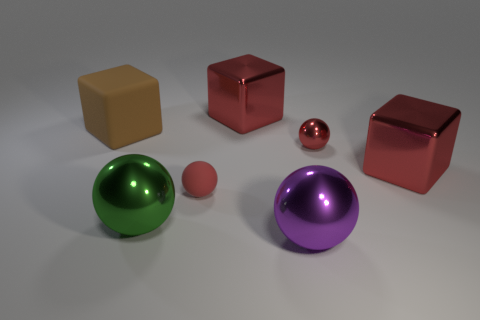Are there any other things that are made of the same material as the large brown cube?
Offer a very short reply. Yes. Is the number of rubber spheres that are behind the large purple shiny sphere the same as the number of blocks to the left of the large rubber thing?
Your response must be concise. No. Are the large brown block and the green thing made of the same material?
Provide a short and direct response. No. How many green objects are balls or small metal spheres?
Your answer should be compact. 1. How many other objects have the same shape as the small metallic thing?
Keep it short and to the point. 3. What is the material of the brown cube?
Your answer should be compact. Rubber. Are there an equal number of large green shiny things that are to the right of the purple metallic object and big brown things?
Keep it short and to the point. No. There is a rubber thing that is the same size as the green ball; what shape is it?
Ensure brevity in your answer.  Cube. There is a matte thing to the right of the green sphere; is there a big thing that is behind it?
Your response must be concise. Yes. How many small things are either purple shiny balls or green spheres?
Make the answer very short. 0. 